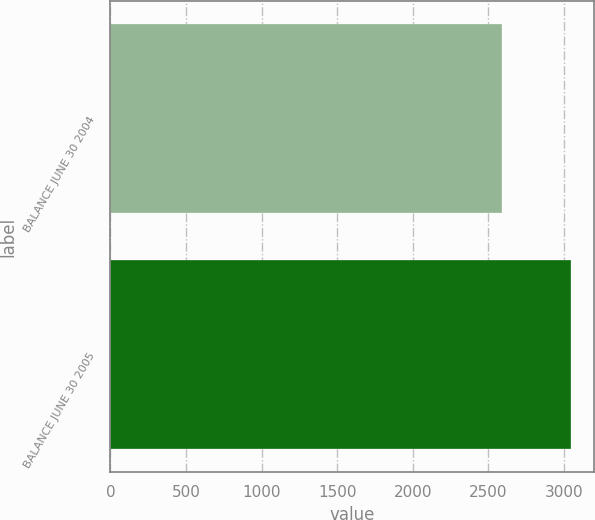<chart> <loc_0><loc_0><loc_500><loc_500><bar_chart><fcel>BALANCE JUNE 30 2004<fcel>BALANCE JUNE 30 2005<nl><fcel>2588.1<fcel>3043.6<nl></chart> 